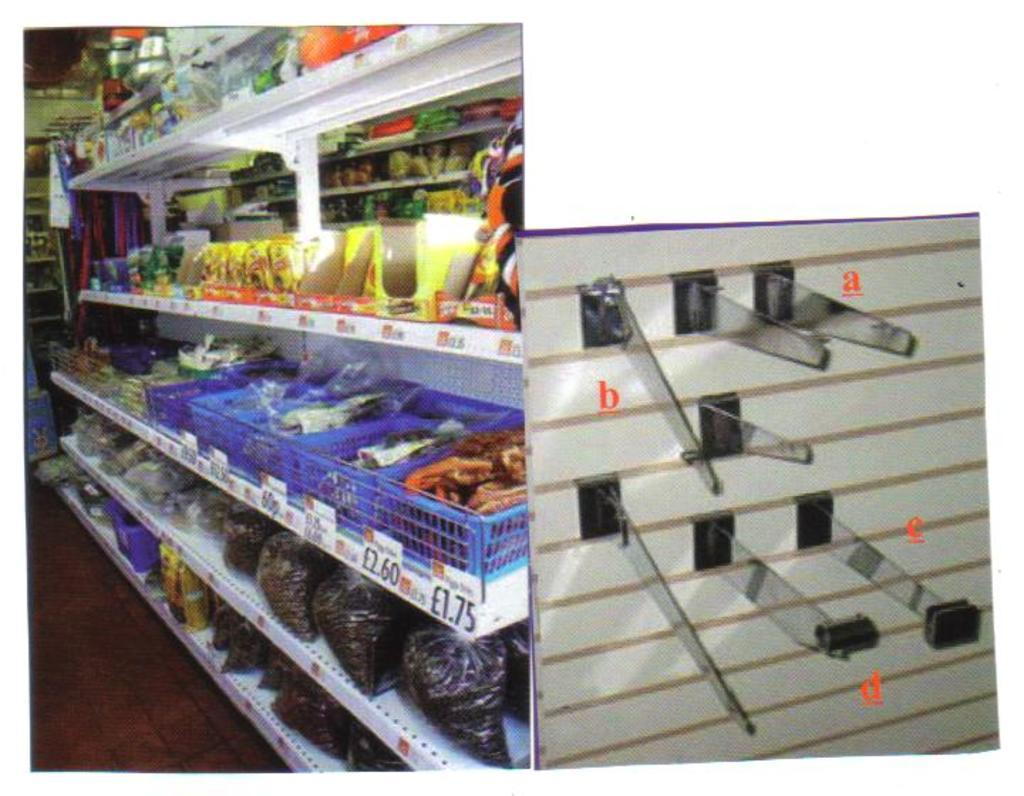<image>
Give a short and clear explanation of the subsequent image. shelves in a store with some prices of 60p, l2.60, and l1.75 